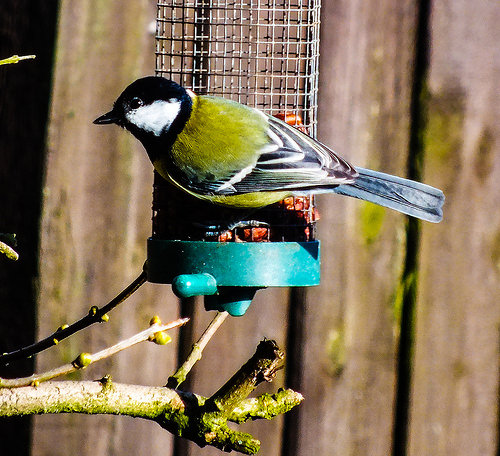<image>
Is the bird on the bird feeder? Yes. Looking at the image, I can see the bird is positioned on top of the bird feeder, with the bird feeder providing support. Where is the bird feeder in relation to the bird? Is it in front of the bird? Yes. The bird feeder is positioned in front of the bird, appearing closer to the camera viewpoint. 